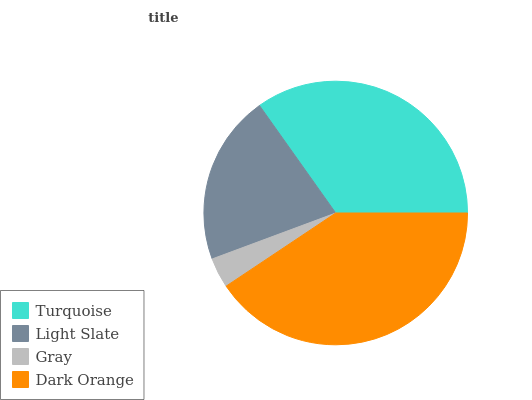Is Gray the minimum?
Answer yes or no. Yes. Is Dark Orange the maximum?
Answer yes or no. Yes. Is Light Slate the minimum?
Answer yes or no. No. Is Light Slate the maximum?
Answer yes or no. No. Is Turquoise greater than Light Slate?
Answer yes or no. Yes. Is Light Slate less than Turquoise?
Answer yes or no. Yes. Is Light Slate greater than Turquoise?
Answer yes or no. No. Is Turquoise less than Light Slate?
Answer yes or no. No. Is Turquoise the high median?
Answer yes or no. Yes. Is Light Slate the low median?
Answer yes or no. Yes. Is Gray the high median?
Answer yes or no. No. Is Gray the low median?
Answer yes or no. No. 